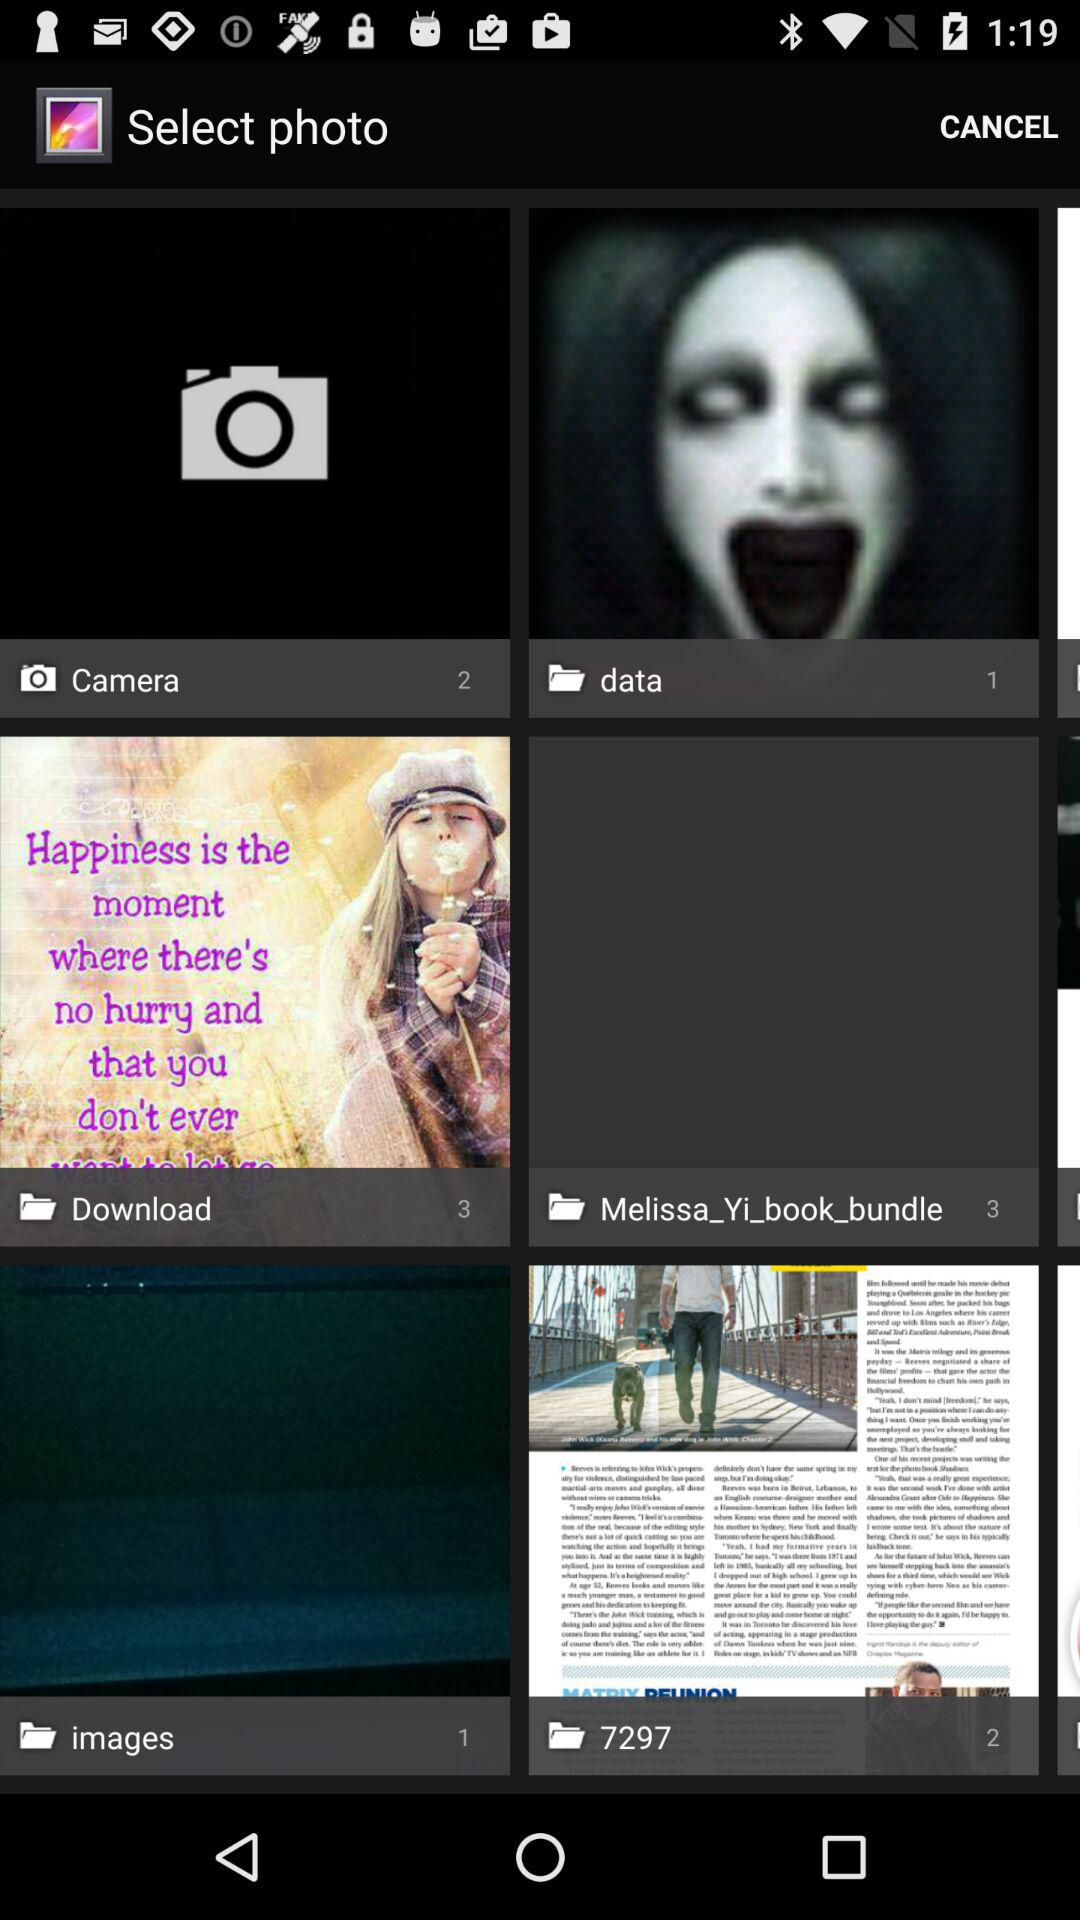How many photos are there in the "data" folder? There is 1 photo. 